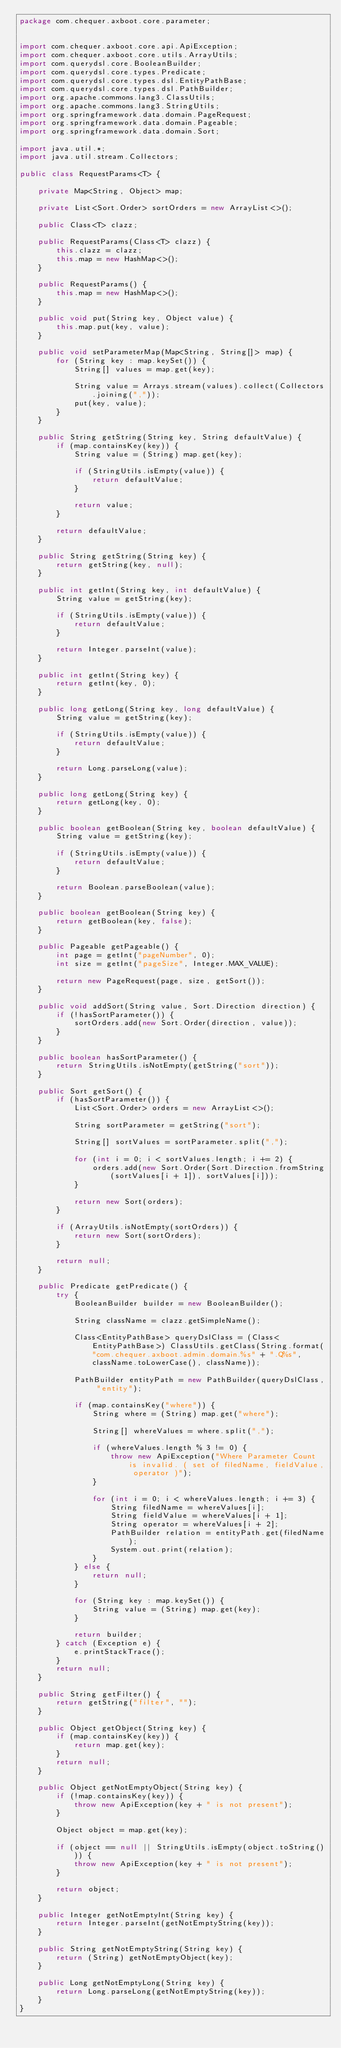Convert code to text. <code><loc_0><loc_0><loc_500><loc_500><_Java_>package com.chequer.axboot.core.parameter;


import com.chequer.axboot.core.api.ApiException;
import com.chequer.axboot.core.utils.ArrayUtils;
import com.querydsl.core.BooleanBuilder;
import com.querydsl.core.types.Predicate;
import com.querydsl.core.types.dsl.EntityPathBase;
import com.querydsl.core.types.dsl.PathBuilder;
import org.apache.commons.lang3.ClassUtils;
import org.apache.commons.lang3.StringUtils;
import org.springframework.data.domain.PageRequest;
import org.springframework.data.domain.Pageable;
import org.springframework.data.domain.Sort;

import java.util.*;
import java.util.stream.Collectors;

public class RequestParams<T> {

    private Map<String, Object> map;

    private List<Sort.Order> sortOrders = new ArrayList<>();

    public Class<T> clazz;

    public RequestParams(Class<T> clazz) {
        this.clazz = clazz;
        this.map = new HashMap<>();
    }

    public RequestParams() {
        this.map = new HashMap<>();
    }

    public void put(String key, Object value) {
        this.map.put(key, value);
    }

    public void setParameterMap(Map<String, String[]> map) {
        for (String key : map.keySet()) {
            String[] values = map.get(key);

            String value = Arrays.stream(values).collect(Collectors.joining(","));
            put(key, value);
        }
    }

    public String getString(String key, String defaultValue) {
        if (map.containsKey(key)) {
            String value = (String) map.get(key);

            if (StringUtils.isEmpty(value)) {
                return defaultValue;
            }

            return value;
        }

        return defaultValue;
    }

    public String getString(String key) {
        return getString(key, null);
    }

    public int getInt(String key, int defaultValue) {
        String value = getString(key);

        if (StringUtils.isEmpty(value)) {
            return defaultValue;
        }

        return Integer.parseInt(value);
    }

    public int getInt(String key) {
        return getInt(key, 0);
    }

    public long getLong(String key, long defaultValue) {
        String value = getString(key);

        if (StringUtils.isEmpty(value)) {
            return defaultValue;
        }

        return Long.parseLong(value);
    }

    public long getLong(String key) {
        return getLong(key, 0);
    }

    public boolean getBoolean(String key, boolean defaultValue) {
        String value = getString(key);

        if (StringUtils.isEmpty(value)) {
            return defaultValue;
        }

        return Boolean.parseBoolean(value);
    }

    public boolean getBoolean(String key) {
        return getBoolean(key, false);
    }

    public Pageable getPageable() {
        int page = getInt("pageNumber", 0);
        int size = getInt("pageSize", Integer.MAX_VALUE);

        return new PageRequest(page, size, getSort());
    }

    public void addSort(String value, Sort.Direction direction) {
        if (!hasSortParameter()) {
            sortOrders.add(new Sort.Order(direction, value));
        }
    }

    public boolean hasSortParameter() {
        return StringUtils.isNotEmpty(getString("sort"));
    }

    public Sort getSort() {
        if (hasSortParameter()) {
            List<Sort.Order> orders = new ArrayList<>();

            String sortParameter = getString("sort");

            String[] sortValues = sortParameter.split(",");

            for (int i = 0; i < sortValues.length; i += 2) {
                orders.add(new Sort.Order(Sort.Direction.fromString(sortValues[i + 1]), sortValues[i]));
            }

            return new Sort(orders);
        }

        if (ArrayUtils.isNotEmpty(sortOrders)) {
            return new Sort(sortOrders);
        }

        return null;
    }

    public Predicate getPredicate() {
        try {
            BooleanBuilder builder = new BooleanBuilder();

            String className = clazz.getSimpleName();

            Class<EntityPathBase> queryDslClass = (Class<EntityPathBase>) ClassUtils.getClass(String.format("com.chequer.axboot.admin.domain.%s" + ".Q%s", className.toLowerCase(), className));

            PathBuilder entityPath = new PathBuilder(queryDslClass, "entity");

            if (map.containsKey("where")) {
                String where = (String) map.get("where");

                String[] whereValues = where.split(",");

                if (whereValues.length % 3 != 0) {
                    throw new ApiException("Where Parameter Count is invalid. ( set of filedName, fieldValue, operator )");
                }

                for (int i = 0; i < whereValues.length; i += 3) {
                    String filedName = whereValues[i];
                    String fieldValue = whereValues[i + 1];
                    String operator = whereValues[i + 2];
                    PathBuilder relation = entityPath.get(filedName);
                    System.out.print(relation);
                }
            } else {
                return null;
            }

            for (String key : map.keySet()) {
                String value = (String) map.get(key);
            }

            return builder;
        } catch (Exception e) {
            e.printStackTrace();
        }
        return null;
    }

    public String getFilter() {
        return getString("filter", "");
    }

    public Object getObject(String key) {
        if (map.containsKey(key)) {
            return map.get(key);
        }
        return null;
    }

    public Object getNotEmptyObject(String key) {
        if (!map.containsKey(key)) {
            throw new ApiException(key + " is not present");
        }

        Object object = map.get(key);

        if (object == null || StringUtils.isEmpty(object.toString())) {
            throw new ApiException(key + " is not present");
        }

        return object;
    }

    public Integer getNotEmptyInt(String key) {
        return Integer.parseInt(getNotEmptyString(key));
    }

    public String getNotEmptyString(String key) {
        return (String) getNotEmptyObject(key);
    }

    public Long getNotEmptyLong(String key) {
        return Long.parseLong(getNotEmptyString(key));
    }
}
</code> 